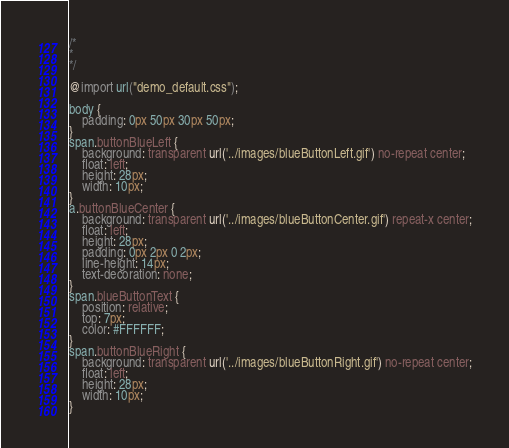Convert code to text. <code><loc_0><loc_0><loc_500><loc_500><_CSS_>/*
*
*/

@import url("demo_default.css");

body {
    padding: 0px 50px 30px 50px;
}
span.buttonBlueLeft {
    background: transparent url('../images/blueButtonLeft.gif') no-repeat center;
    float: left;
    height: 28px;
    width: 10px;
}
a.buttonBlueCenter {
    background: transparent url('../images/blueButtonCenter.gif') repeat-x center;
    float: left;
    height: 28px;
    padding: 0px 2px 0 2px;
    line-height: 14px;
    text-decoration: none;
}
span.blueButtonText {
    position: relative;
    top: 7px;
    color: #FFFFFF;
}
span.buttonBlueRight {
    background: transparent url('../images/blueButtonRight.gif') no-repeat center;
    float: left;
    height: 28px;
    width: 10px;
}
</code> 